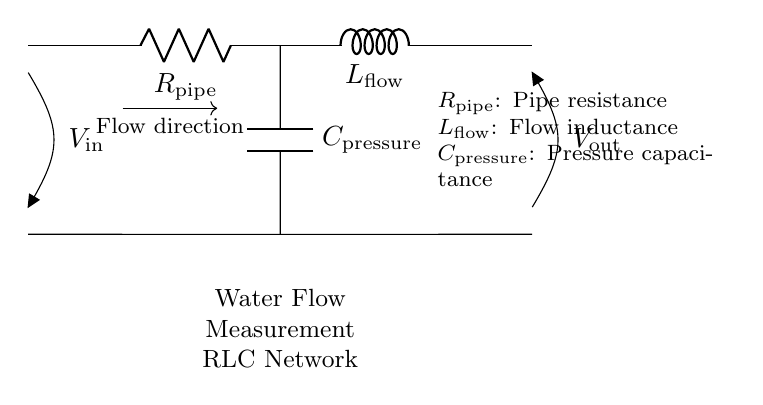What is the role of the resistor in this circuit? The resistor represents the resistance of the pipeline, influencing the flow rate and pressure drop within the system.
Answer: Pipe resistance What does the inductor in the circuit indicate? The inductor signifies the flow inductance, which relates to the velocity changes of water in the pipeline, reflecting how quickly the flow can change.
Answer: Flow inductance What is the purpose of the capacitor in this circuit? The capacitor represents pressure capacitance, which indicates the ability to store energy in the pressure field caused by changing flow rates.
Answer: Pressure capacitance What is the input voltage denoted as in this circuit? The input voltage is labeled as "V in," representing the voltage at the entry point of the water flow measurement system.
Answer: V in How do the components of this RLC network interact in relation to flow measurement? The resistor, inductor, and capacitor together form a dynamic system that responds to changes in flow, voltage, and pressure, enabling real-time measurement of flow conditions.
Answer: Dynamic measurement system What would happen if the value of the resistor is increased? Increasing the resistor value would raise the resistance, resulting in a lower flow rate and a higher pressure drop across the pipeline, affecting measurement accuracy.
Answer: Lower flow rate What does the output voltage "V out" represent in this circuit? The output voltage "V out" indicates the voltage at the output terminal, reflecting the resultant pressure and flow characteristics after passing through the RLC network.
Answer: V out 